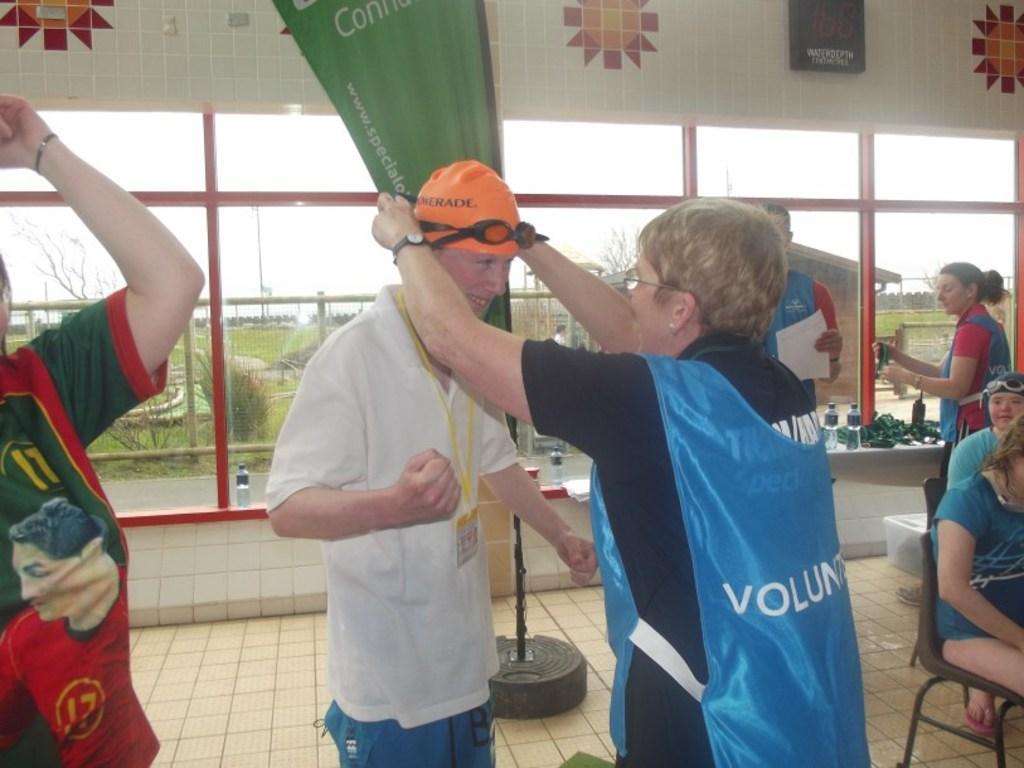Describe this image in one or two sentences. In this picture we can see some people standing here, on the right side there are two persons sitting on chairs, in the background there is a glass, from the glass we can see grass and the sky. 